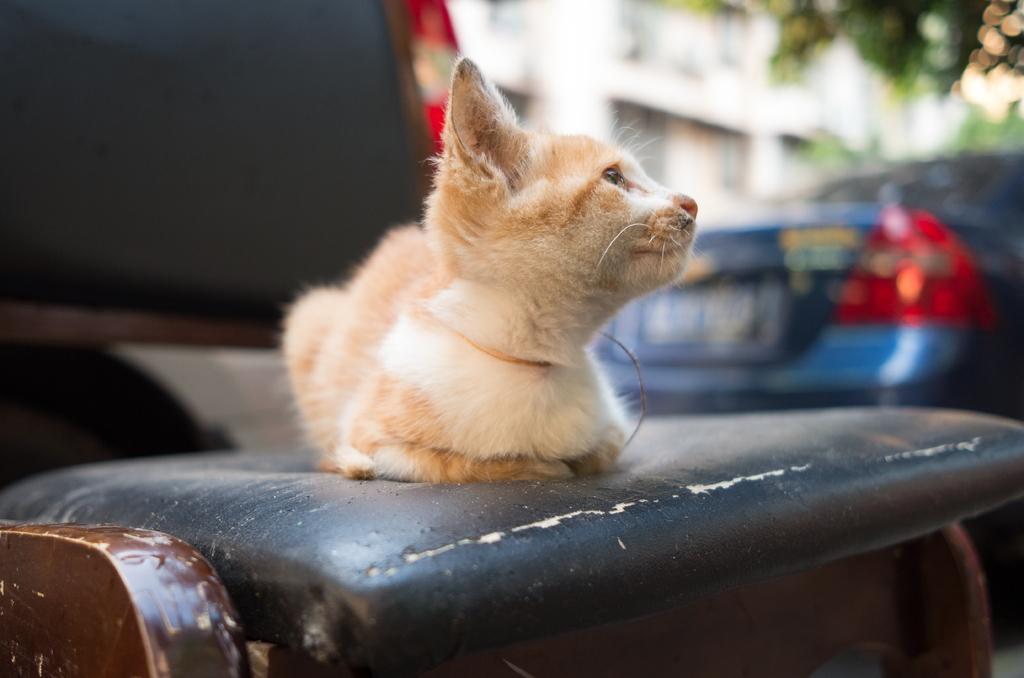Could you give a brief overview of what you see in this image? In this picture, we see the cat is on the sofa chair. On the right side, we see a blue car. In the background, we see the trees and a building in white color. This picture is blurred in the background. On the left side, we see a black color vehicle. 